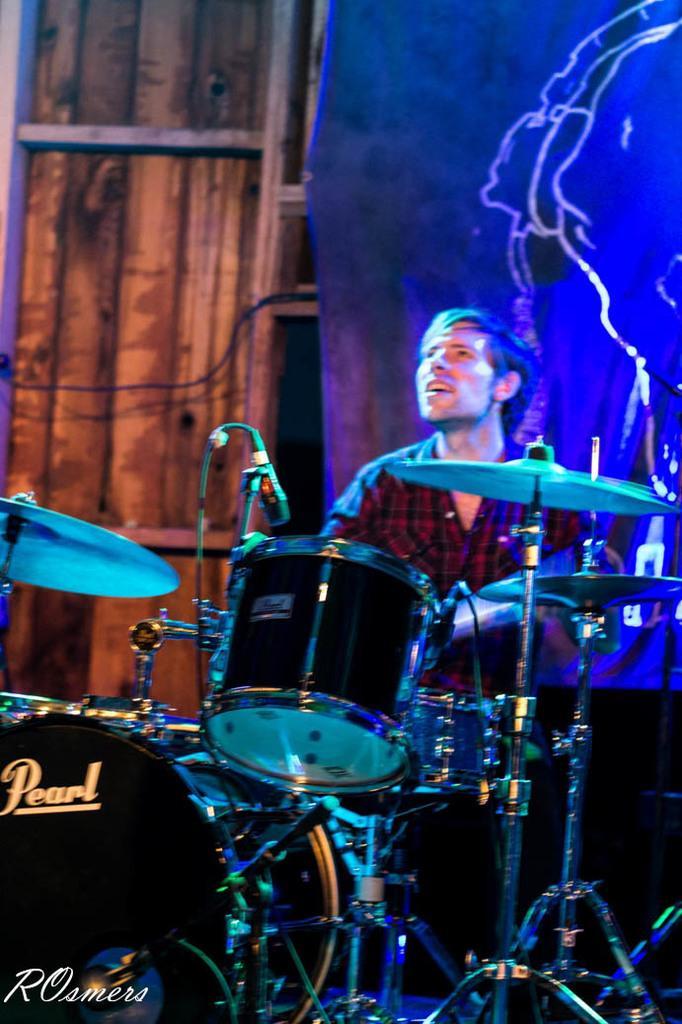In one or two sentences, can you explain what this image depicts? This image consists of a man wearing a red shirt is playing drums. In the front, we can see a band setup. In the background, there is a banner and a wooden wall. 